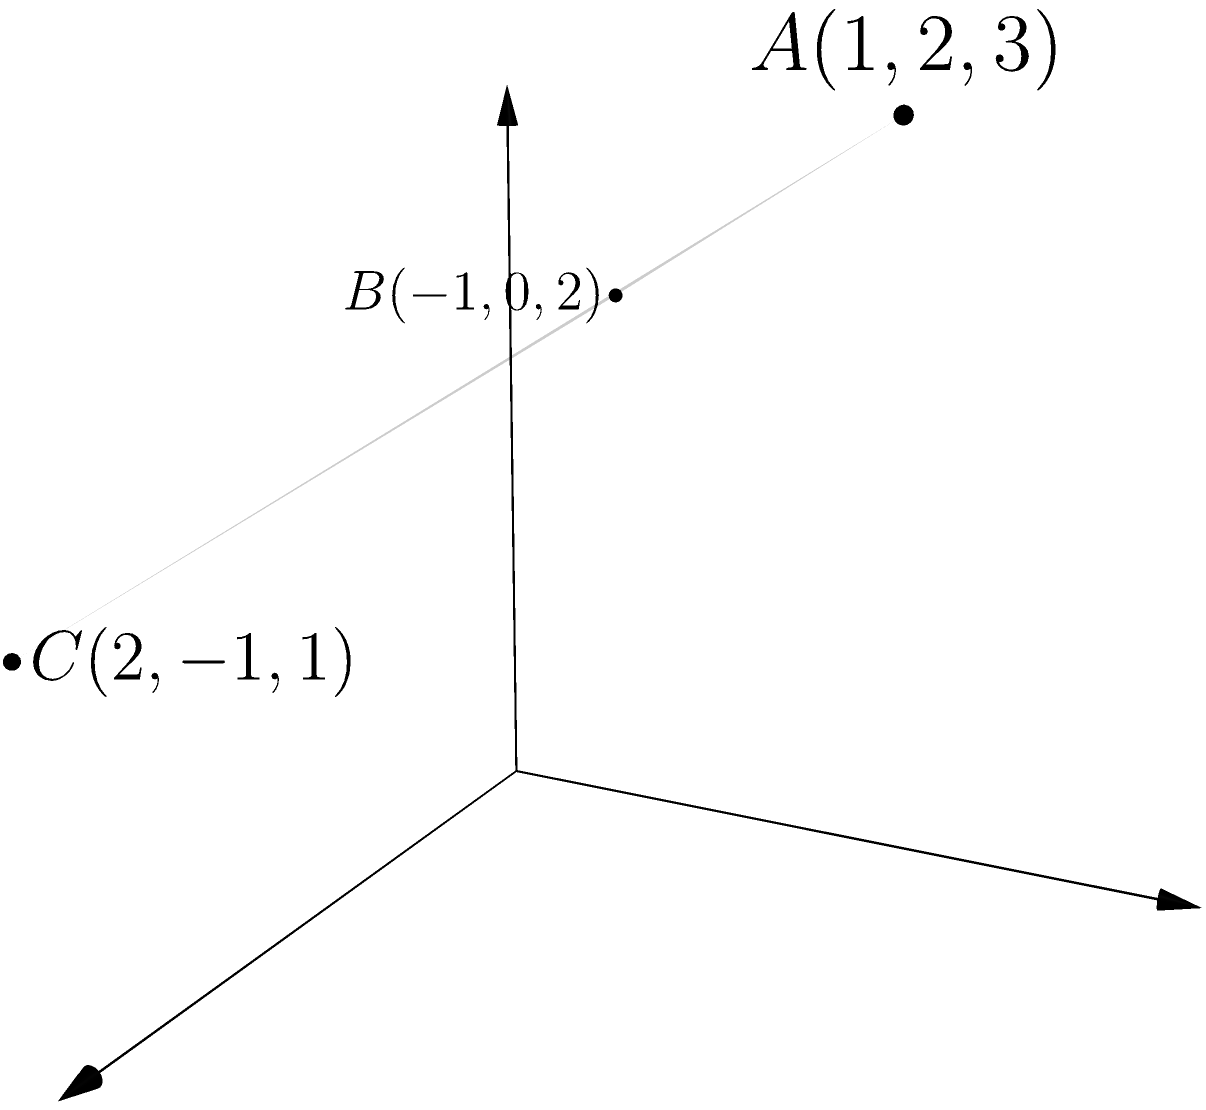As a researcher working on advanced geometric models, you encounter a problem related to the Iranian nuclear program's containment facilities. Given three non-collinear points $A(1,2,3)$, $B(-1,0,2)$, and $C(2,-1,1)$ representing key structural points in a facility, determine the equation of the plane passing through these points. Express your answer in the form $ax + by + cz + d = 0$, where $a$, $b$, $c$, and $d$ are integers, and $a > 0$. To find the equation of a plane passing through three non-collinear points, we can follow these steps:

1) First, we need to find two vectors on the plane. We can do this by subtracting the coordinates of two points from the third:

   $\vec{AB} = B - A = (-1-1, 0-2, 2-3) = (-2, -2, -1)$
   $\vec{AC} = C - A = (2-1, -1-2, 1-3) = (1, -3, -2)$

2) The normal vector to the plane will be the cross product of these two vectors:

   $\vec{n} = \vec{AB} \times \vec{AC} = \begin{vmatrix} 
   i & j & k \\
   -2 & -2 & -1 \\
   1 & -3 & -2
   \end{vmatrix}$

   $= (-2(-2) - (-1)(-3))i + (-(-1)(1) - (-2)(-2))j + (-2(1) - (-2)(-3))k$
   $= (-4 + 3)i + (-1 + 4)j + (-2 + 6)k$
   $= -i + 3j + 4k$

3) The equation of a plane is $ax + by + cz + d = 0$, where $(a,b,c)$ is the normal vector. So our equation is:

   $-x + 3y + 4z + d = 0$

4) To find $d$, we can substitute the coordinates of any of the given points. Let's use $A(1,2,3)$:

   $-1 + 3(2) + 4(3) + d = 0$
   $-1 + 6 + 12 + d = 0$
   $17 + d = 0$
   $d = -17$

5) Therefore, the equation of the plane is:

   $-x + 3y + 4z - 17 = 0$

6) However, the question asks for the equation where the coefficient of $x$ is positive. We can achieve this by multiplying the entire equation by -1:

   $x - 3y - 4z + 17 = 0$

This is our final answer, with $a=1$, $b=-3$, $c=-4$, and $d=17$.
Answer: $x - 3y - 4z + 17 = 0$ 